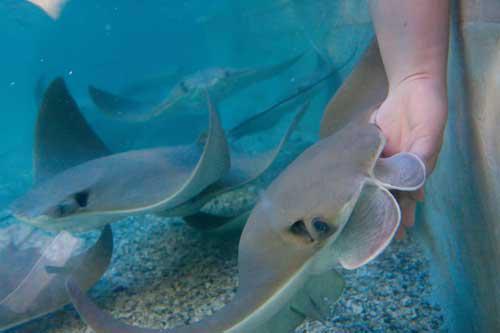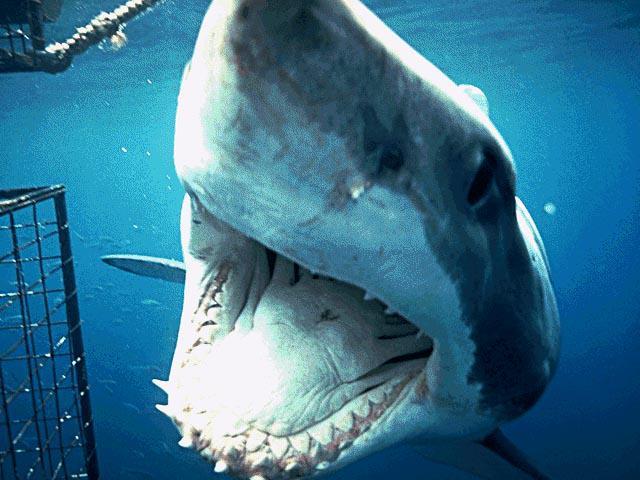The first image is the image on the left, the second image is the image on the right. Assess this claim about the two images: "There is a close up of human hands petting the stingrays.". Correct or not? Answer yes or no. Yes. The first image is the image on the left, the second image is the image on the right. Assess this claim about the two images: "At least one person is interacting with a marine animal at the water's surface.". Correct or not? Answer yes or no. No. 